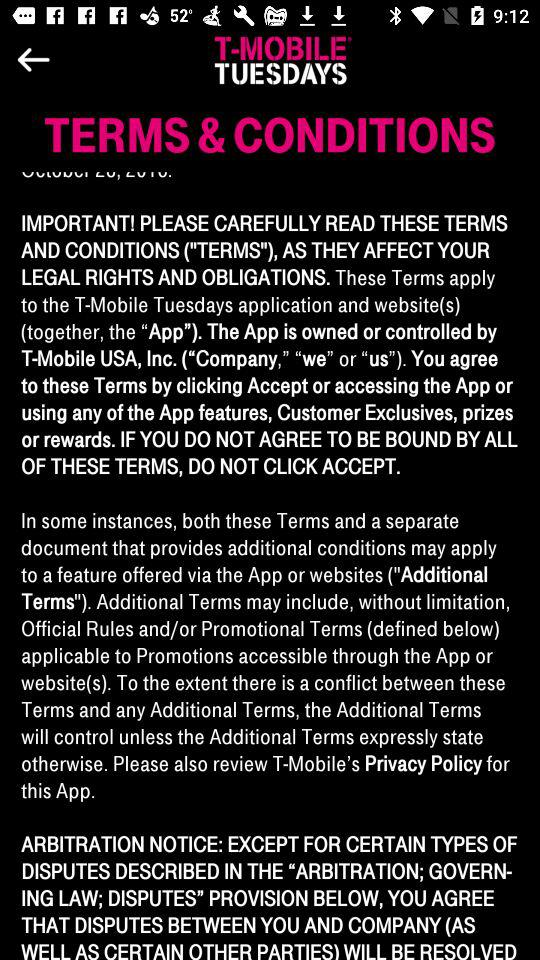What day is the countdown ending? The day is "TUESDAY". 